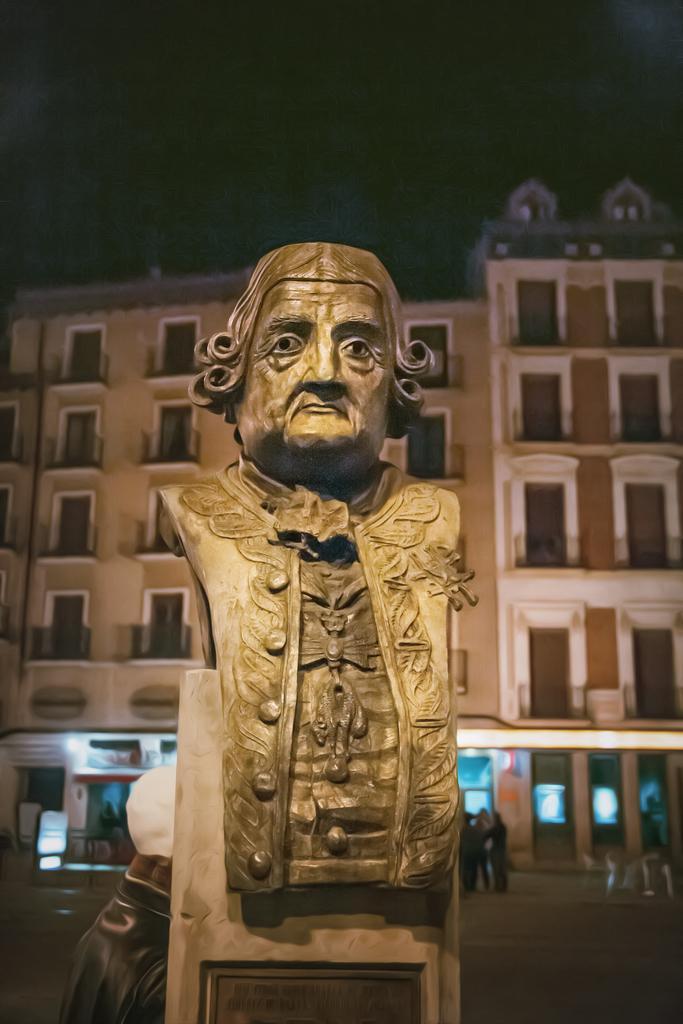Can you describe this image briefly? In the image I can see a statue and behind there are some buildings and some people. 